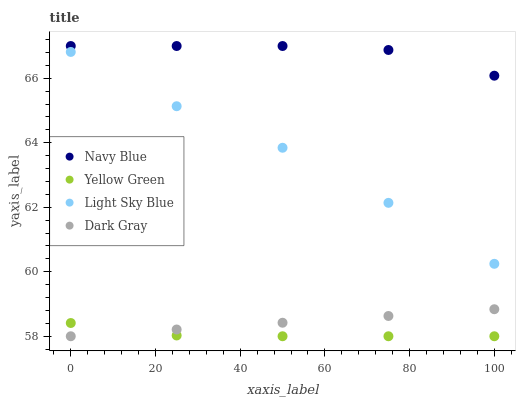Does Yellow Green have the minimum area under the curve?
Answer yes or no. Yes. Does Navy Blue have the maximum area under the curve?
Answer yes or no. Yes. Does Light Sky Blue have the minimum area under the curve?
Answer yes or no. No. Does Light Sky Blue have the maximum area under the curve?
Answer yes or no. No. Is Dark Gray the smoothest?
Answer yes or no. Yes. Is Light Sky Blue the roughest?
Answer yes or no. Yes. Is Navy Blue the smoothest?
Answer yes or no. No. Is Navy Blue the roughest?
Answer yes or no. No. Does Dark Gray have the lowest value?
Answer yes or no. Yes. Does Light Sky Blue have the lowest value?
Answer yes or no. No. Does Navy Blue have the highest value?
Answer yes or no. Yes. Does Light Sky Blue have the highest value?
Answer yes or no. No. Is Dark Gray less than Navy Blue?
Answer yes or no. Yes. Is Navy Blue greater than Dark Gray?
Answer yes or no. Yes. Does Dark Gray intersect Yellow Green?
Answer yes or no. Yes. Is Dark Gray less than Yellow Green?
Answer yes or no. No. Is Dark Gray greater than Yellow Green?
Answer yes or no. No. Does Dark Gray intersect Navy Blue?
Answer yes or no. No. 